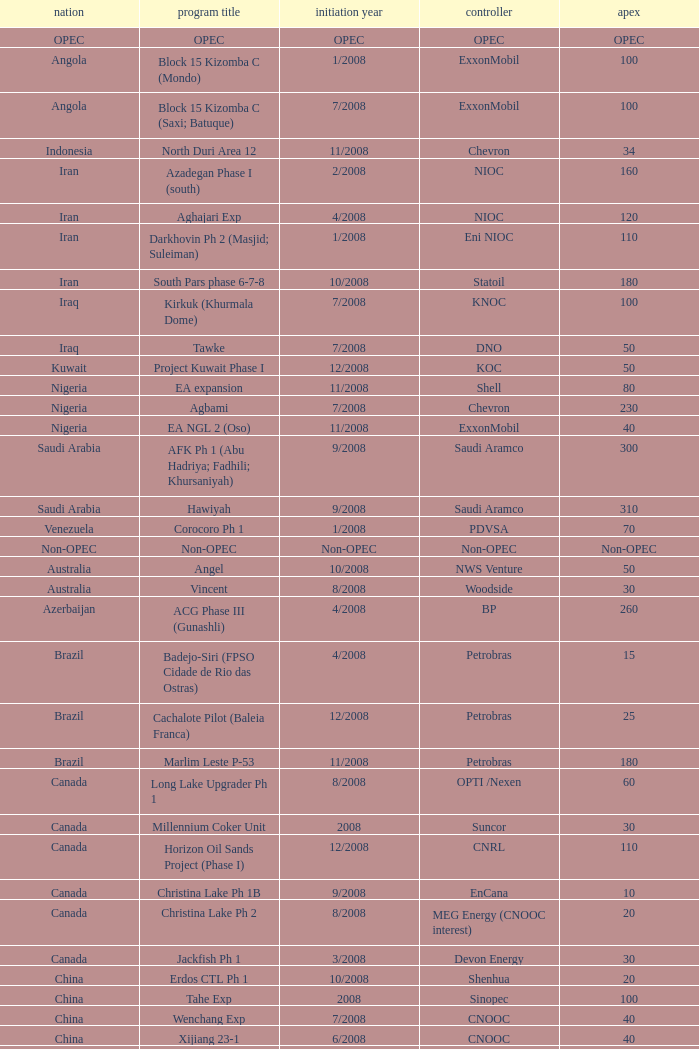What is the Operator with a Peak that is 55? PEMEX. 